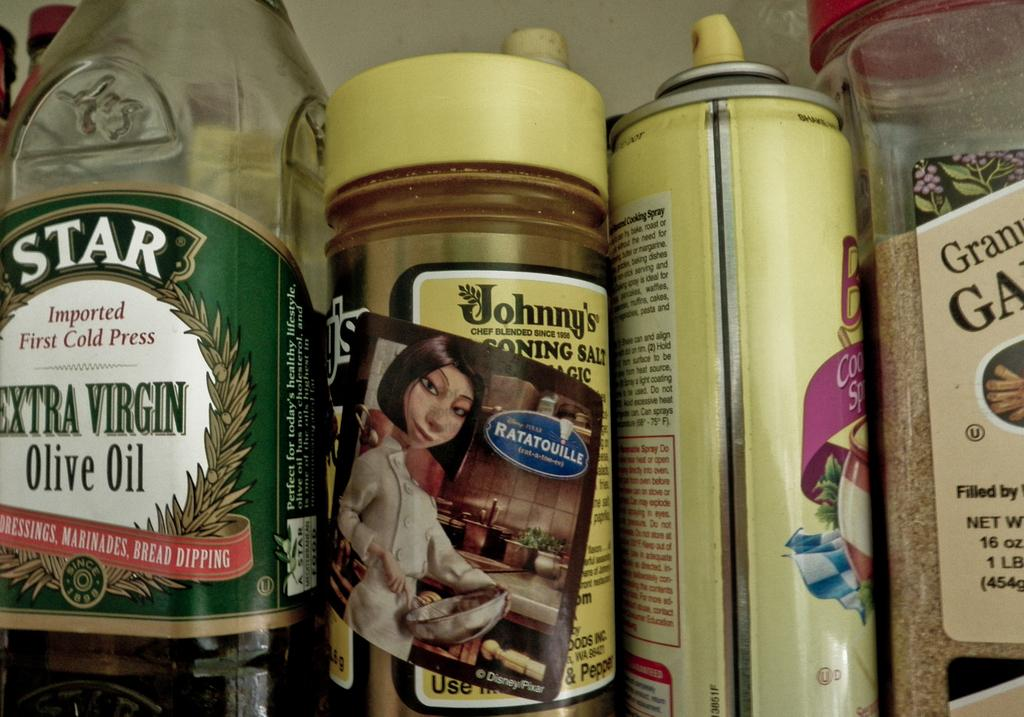<image>
Provide a brief description of the given image. Kitchen items including Johnny's brand seasoning salt and some cooking spray. 